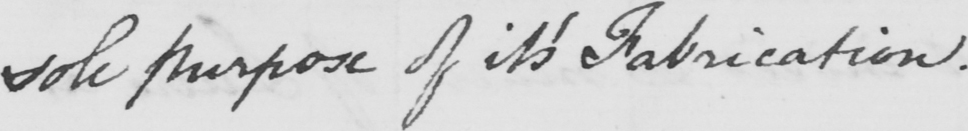Can you tell me what this handwritten text says? sole purpose of its Fabrication . 